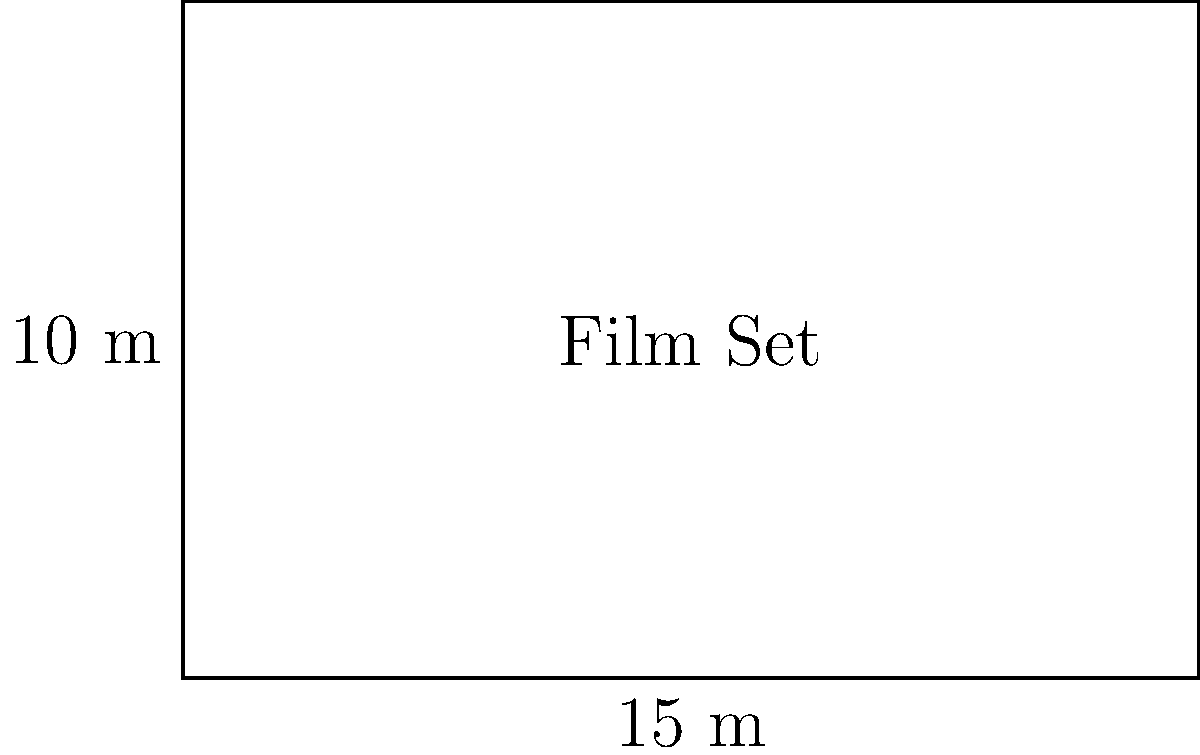You're planning a new film set for an upcoming Iranian-international co-production. The rectangular set measures 15 meters in length and 10 meters in width. What is the total area of this film set in square meters? To find the area of a rectangular film set, we need to multiply its length by its width. Let's break it down step-by-step:

1. Given dimensions:
   - Length = 15 meters
   - Width = 10 meters

2. The formula for the area of a rectangle is:
   $$ A = l \times w $$
   Where $A$ is the area, $l$ is the length, and $w$ is the width.

3. Plugging in our values:
   $$ A = 15 \text{ m} \times 10 \text{ m} $$

4. Multiplying:
   $$ A = 150 \text{ m}^2 $$

Therefore, the total area of the film set is 150 square meters.
Answer: 150 m² 